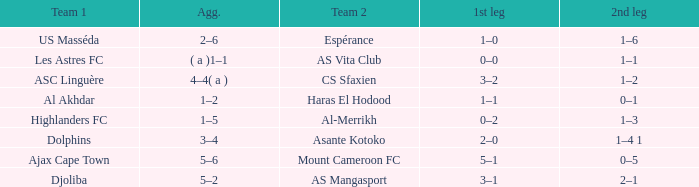What is the 2nd leg of team 1 Dolphins? 1–4 1. 